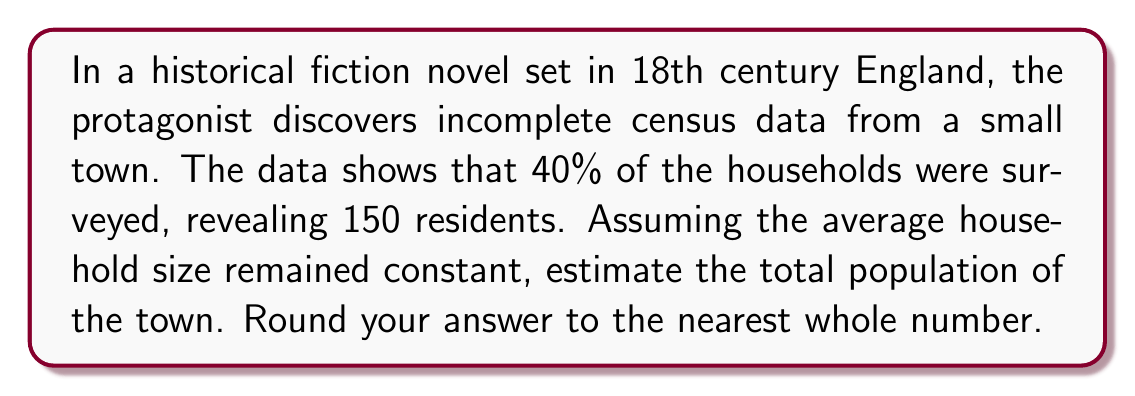Can you solve this math problem? To solve this inverse problem and estimate the total population, we'll follow these steps:

1) Let's define our variables:
   $x$ = total number of households
   $y$ = total population

2) We know that 40% of households were surveyed. This can be expressed as:
   $0.4x$ = number of households surveyed

3) The surveyed households contained 150 residents. We can express this as:
   $\frac{150}{0.4x}$ = average household size

4) Assuming this average household size is constant for the entire town, we can set up the equation:
   $y = x \cdot \frac{150}{0.4x}$

5) Simplify the equation:
   $y = \frac{150}{0.4} = 375$

6) Therefore, the estimated total population is 375.

7) As the question asks for the nearest whole number, we don't need to round in this case.
Answer: 375 